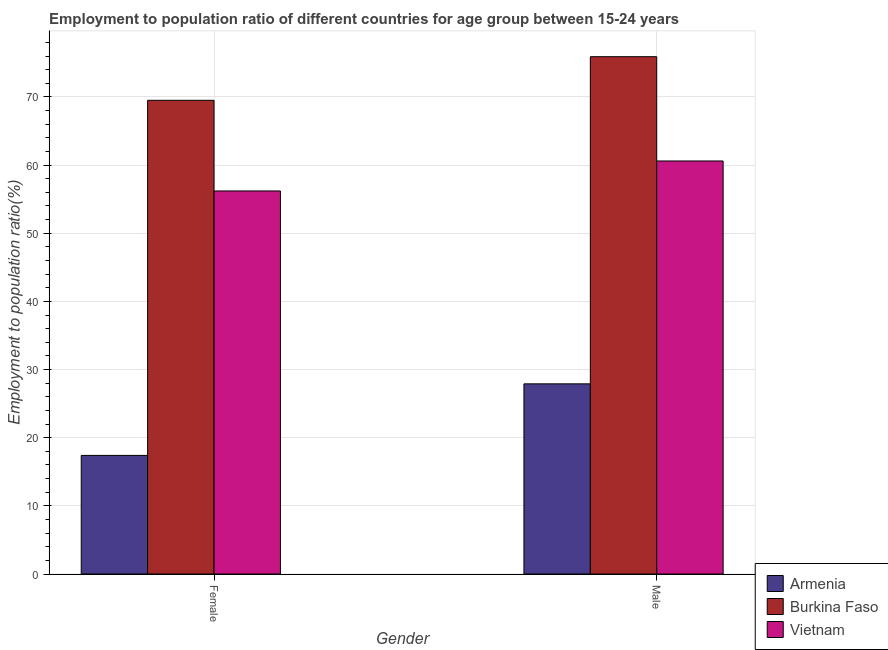How many groups of bars are there?
Make the answer very short. 2. How many bars are there on the 2nd tick from the left?
Provide a succinct answer. 3. How many bars are there on the 2nd tick from the right?
Your answer should be very brief. 3. What is the label of the 2nd group of bars from the left?
Provide a succinct answer. Male. What is the employment to population ratio(female) in Burkina Faso?
Ensure brevity in your answer.  69.5. Across all countries, what is the maximum employment to population ratio(male)?
Keep it short and to the point. 75.9. Across all countries, what is the minimum employment to population ratio(female)?
Provide a short and direct response. 17.4. In which country was the employment to population ratio(male) maximum?
Provide a succinct answer. Burkina Faso. In which country was the employment to population ratio(female) minimum?
Provide a succinct answer. Armenia. What is the total employment to population ratio(male) in the graph?
Make the answer very short. 164.4. What is the difference between the employment to population ratio(male) in Burkina Faso and that in Armenia?
Your answer should be very brief. 48. What is the difference between the employment to population ratio(female) in Burkina Faso and the employment to population ratio(male) in Vietnam?
Your answer should be very brief. 8.9. What is the average employment to population ratio(male) per country?
Give a very brief answer. 54.8. What is the difference between the employment to population ratio(female) and employment to population ratio(male) in Burkina Faso?
Your response must be concise. -6.4. What is the ratio of the employment to population ratio(female) in Burkina Faso to that in Vietnam?
Your response must be concise. 1.24. Is the employment to population ratio(female) in Armenia less than that in Vietnam?
Your answer should be very brief. Yes. What does the 2nd bar from the left in Female represents?
Offer a terse response. Burkina Faso. What does the 2nd bar from the right in Female represents?
Provide a succinct answer. Burkina Faso. How many countries are there in the graph?
Your answer should be compact. 3. Are the values on the major ticks of Y-axis written in scientific E-notation?
Your answer should be compact. No. How many legend labels are there?
Offer a terse response. 3. What is the title of the graph?
Give a very brief answer. Employment to population ratio of different countries for age group between 15-24 years. What is the label or title of the X-axis?
Provide a short and direct response. Gender. What is the Employment to population ratio(%) of Armenia in Female?
Your answer should be compact. 17.4. What is the Employment to population ratio(%) in Burkina Faso in Female?
Your answer should be very brief. 69.5. What is the Employment to population ratio(%) in Vietnam in Female?
Your response must be concise. 56.2. What is the Employment to population ratio(%) of Armenia in Male?
Your answer should be very brief. 27.9. What is the Employment to population ratio(%) of Burkina Faso in Male?
Give a very brief answer. 75.9. What is the Employment to population ratio(%) of Vietnam in Male?
Your response must be concise. 60.6. Across all Gender, what is the maximum Employment to population ratio(%) of Armenia?
Provide a short and direct response. 27.9. Across all Gender, what is the maximum Employment to population ratio(%) in Burkina Faso?
Offer a terse response. 75.9. Across all Gender, what is the maximum Employment to population ratio(%) of Vietnam?
Provide a short and direct response. 60.6. Across all Gender, what is the minimum Employment to population ratio(%) in Armenia?
Ensure brevity in your answer.  17.4. Across all Gender, what is the minimum Employment to population ratio(%) in Burkina Faso?
Offer a very short reply. 69.5. Across all Gender, what is the minimum Employment to population ratio(%) of Vietnam?
Ensure brevity in your answer.  56.2. What is the total Employment to population ratio(%) of Armenia in the graph?
Your answer should be very brief. 45.3. What is the total Employment to population ratio(%) of Burkina Faso in the graph?
Provide a short and direct response. 145.4. What is the total Employment to population ratio(%) in Vietnam in the graph?
Your answer should be compact. 116.8. What is the difference between the Employment to population ratio(%) in Burkina Faso in Female and that in Male?
Your response must be concise. -6.4. What is the difference between the Employment to population ratio(%) of Armenia in Female and the Employment to population ratio(%) of Burkina Faso in Male?
Give a very brief answer. -58.5. What is the difference between the Employment to population ratio(%) of Armenia in Female and the Employment to population ratio(%) of Vietnam in Male?
Offer a terse response. -43.2. What is the average Employment to population ratio(%) in Armenia per Gender?
Your answer should be very brief. 22.65. What is the average Employment to population ratio(%) of Burkina Faso per Gender?
Offer a very short reply. 72.7. What is the average Employment to population ratio(%) of Vietnam per Gender?
Offer a very short reply. 58.4. What is the difference between the Employment to population ratio(%) of Armenia and Employment to population ratio(%) of Burkina Faso in Female?
Your response must be concise. -52.1. What is the difference between the Employment to population ratio(%) in Armenia and Employment to population ratio(%) in Vietnam in Female?
Your answer should be very brief. -38.8. What is the difference between the Employment to population ratio(%) in Armenia and Employment to population ratio(%) in Burkina Faso in Male?
Your answer should be compact. -48. What is the difference between the Employment to population ratio(%) in Armenia and Employment to population ratio(%) in Vietnam in Male?
Give a very brief answer. -32.7. What is the difference between the Employment to population ratio(%) in Burkina Faso and Employment to population ratio(%) in Vietnam in Male?
Offer a terse response. 15.3. What is the ratio of the Employment to population ratio(%) of Armenia in Female to that in Male?
Your answer should be compact. 0.62. What is the ratio of the Employment to population ratio(%) in Burkina Faso in Female to that in Male?
Provide a succinct answer. 0.92. What is the ratio of the Employment to population ratio(%) in Vietnam in Female to that in Male?
Make the answer very short. 0.93. What is the difference between the highest and the second highest Employment to population ratio(%) of Burkina Faso?
Make the answer very short. 6.4. What is the difference between the highest and the second highest Employment to population ratio(%) of Vietnam?
Make the answer very short. 4.4. What is the difference between the highest and the lowest Employment to population ratio(%) in Burkina Faso?
Make the answer very short. 6.4. 